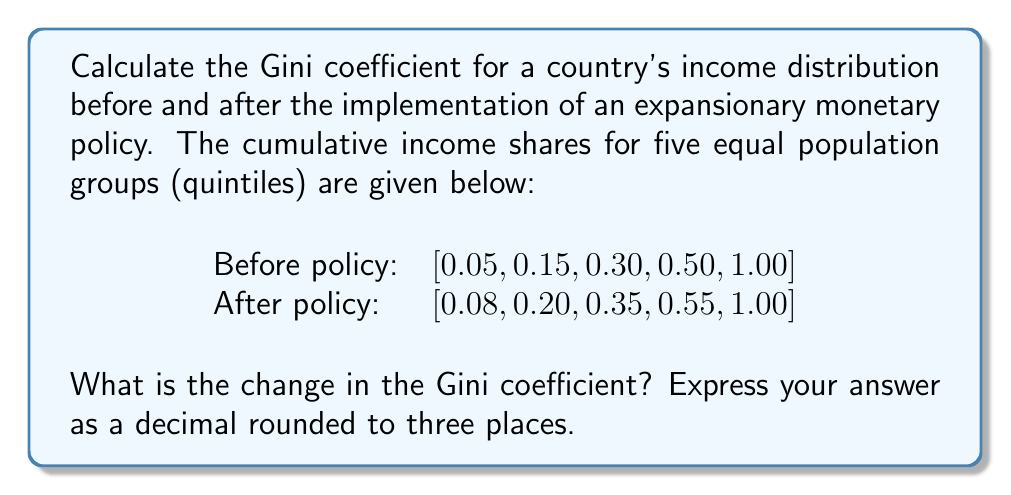Solve this math problem. To solve this problem, we'll follow these steps:

1. Calculate the Gini coefficient for each distribution using the formula:

   $$G = 1 - \sum_{i=1}^{n} (X_i - X_{i-1})(Y_i + Y_{i-1})$$

   where $X_i$ is the cumulative proportion of the population, and $Y_i$ is the cumulative proportion of income.

2. For the distribution before the policy:

   $$G_{before} = 1 - [(0.2 - 0)(0.05 + 0) + (0.4 - 0.2)(0.15 + 0.05) + (0.6 - 0.4)(0.30 + 0.15) + (0.8 - 0.6)(0.50 + 0.30) + (1 - 0.8)(1 + 0.50)]$$
   
   $$G_{before} = 1 - [0.01 + 0.04 + 0.09 + 0.16 + 0.30] = 1 - 0.60 = 0.40$$

3. For the distribution after the policy:

   $$G_{after} = 1 - [(0.2 - 0)(0.08 + 0) + (0.4 - 0.2)(0.20 + 0.08) + (0.6 - 0.4)(0.35 + 0.20) + (0.8 - 0.6)(0.55 + 0.35) + (1 - 0.8)(1 + 0.55)]$$
   
   $$G_{after} = 1 - [0.016 + 0.056 + 0.110 + 0.180 + 0.310] = 1 - 0.672 = 0.328$$

4. Calculate the change in Gini coefficient:

   $$\Delta G = G_{after} - G_{before} = 0.328 - 0.400 = -0.072$$

5. Round the result to three decimal places: -0.072

The negative value indicates a decrease in income inequality after the implementation of the expansionary monetary policy.
Answer: -0.072 